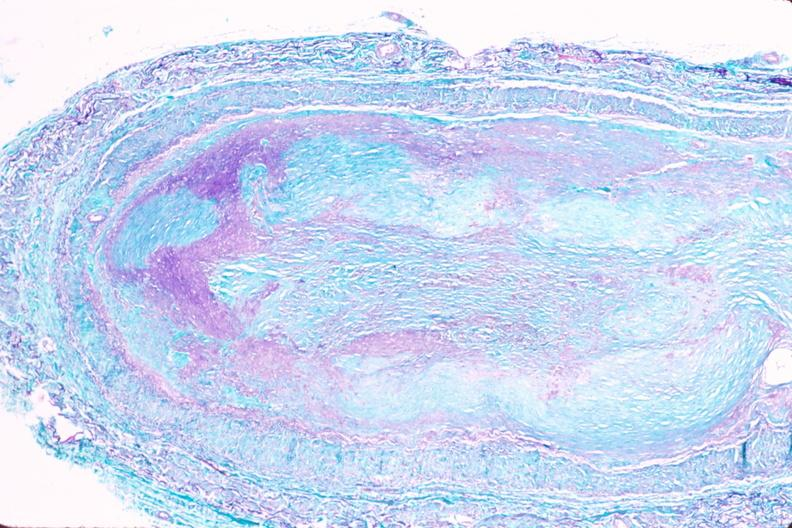what does this image show?
Answer the question using a single word or phrase. Saphenous vein graft sclerosis 